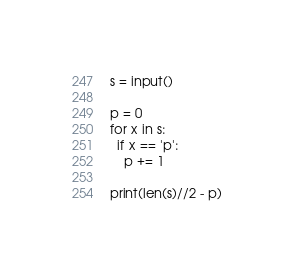<code> <loc_0><loc_0><loc_500><loc_500><_Python_>s = input()

p = 0
for x in s:
  if x == 'p':
    p += 1
    
print(len(s)//2 - p)</code> 